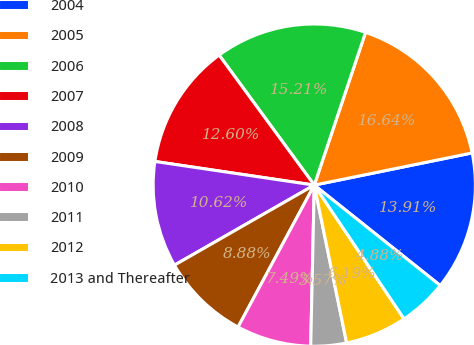<chart> <loc_0><loc_0><loc_500><loc_500><pie_chart><fcel>2004<fcel>2005<fcel>2006<fcel>2007<fcel>2008<fcel>2009<fcel>2010<fcel>2011<fcel>2012<fcel>2013 and Thereafter<nl><fcel>13.91%<fcel>16.64%<fcel>15.21%<fcel>12.6%<fcel>10.62%<fcel>8.88%<fcel>7.49%<fcel>3.57%<fcel>6.19%<fcel>4.88%<nl></chart> 